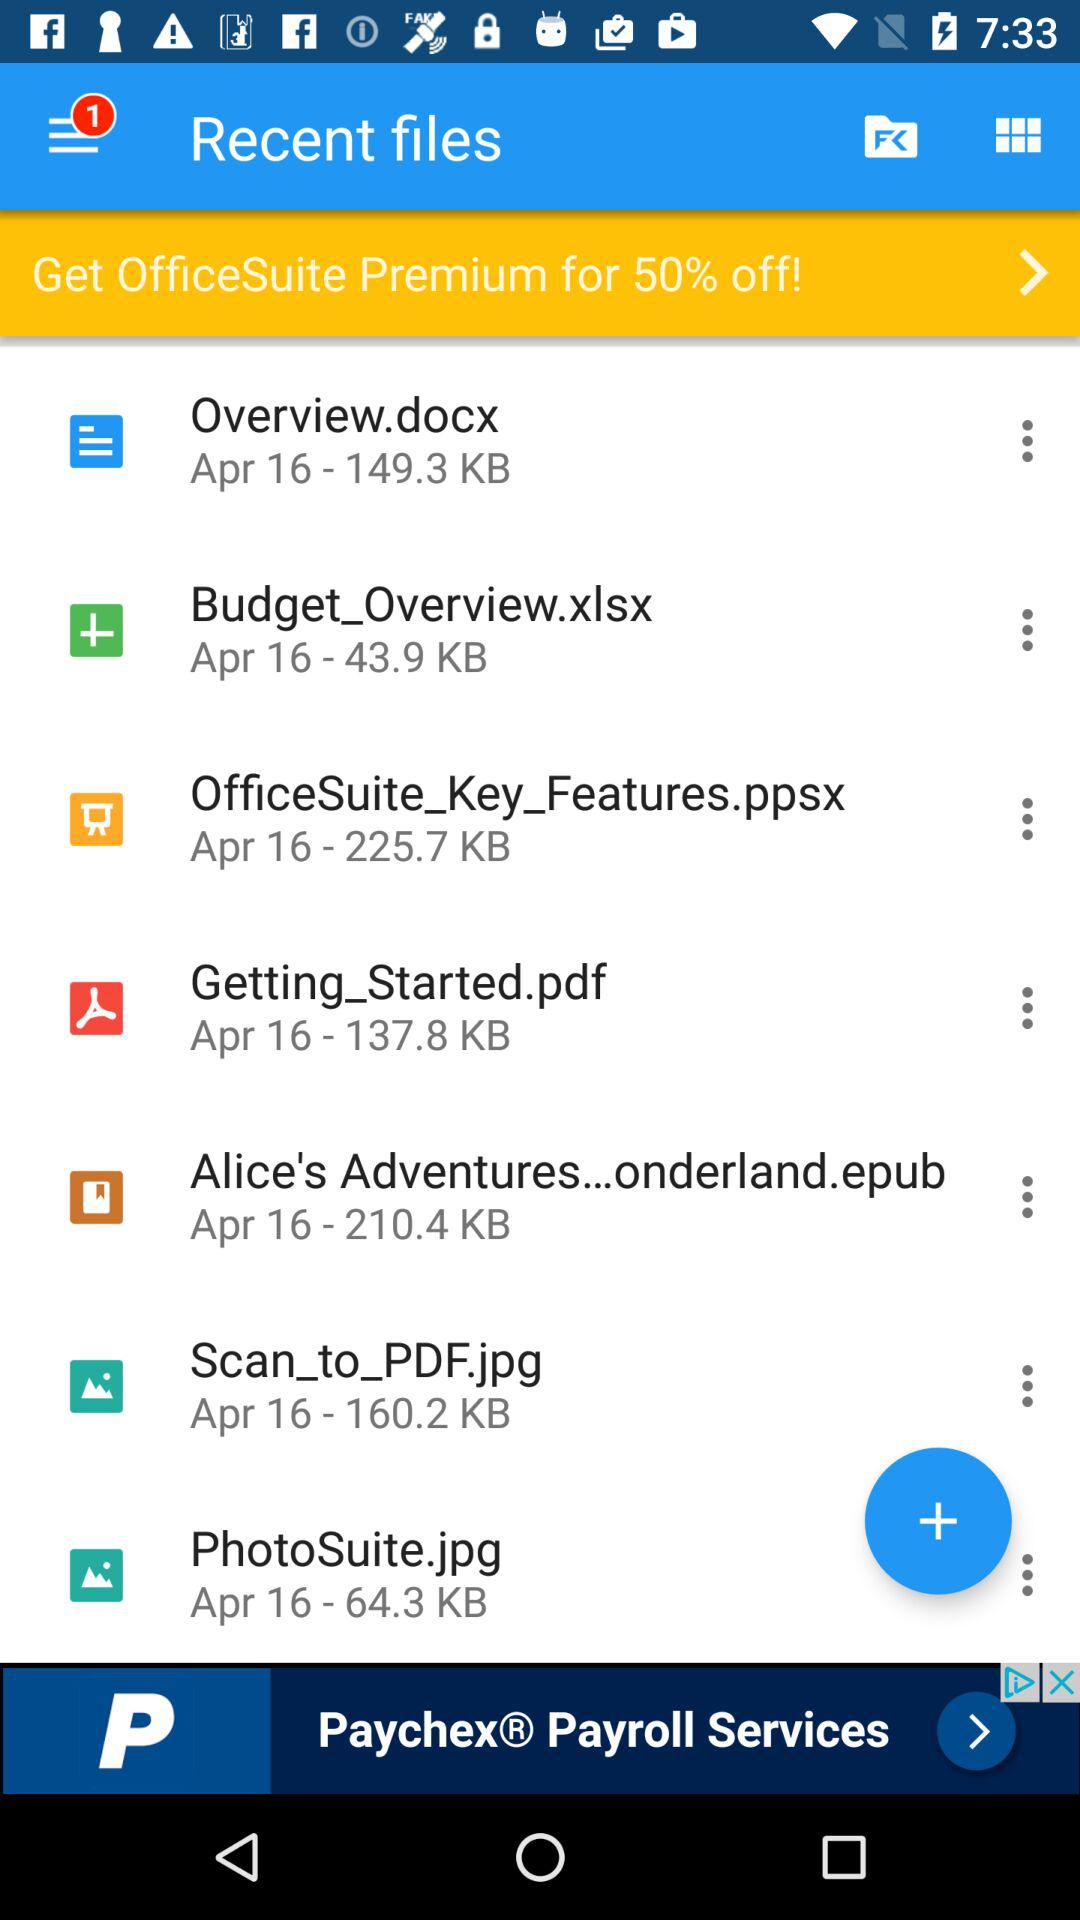What's the date of the "PhotoSuite.jpg" file? The date is April 16. 